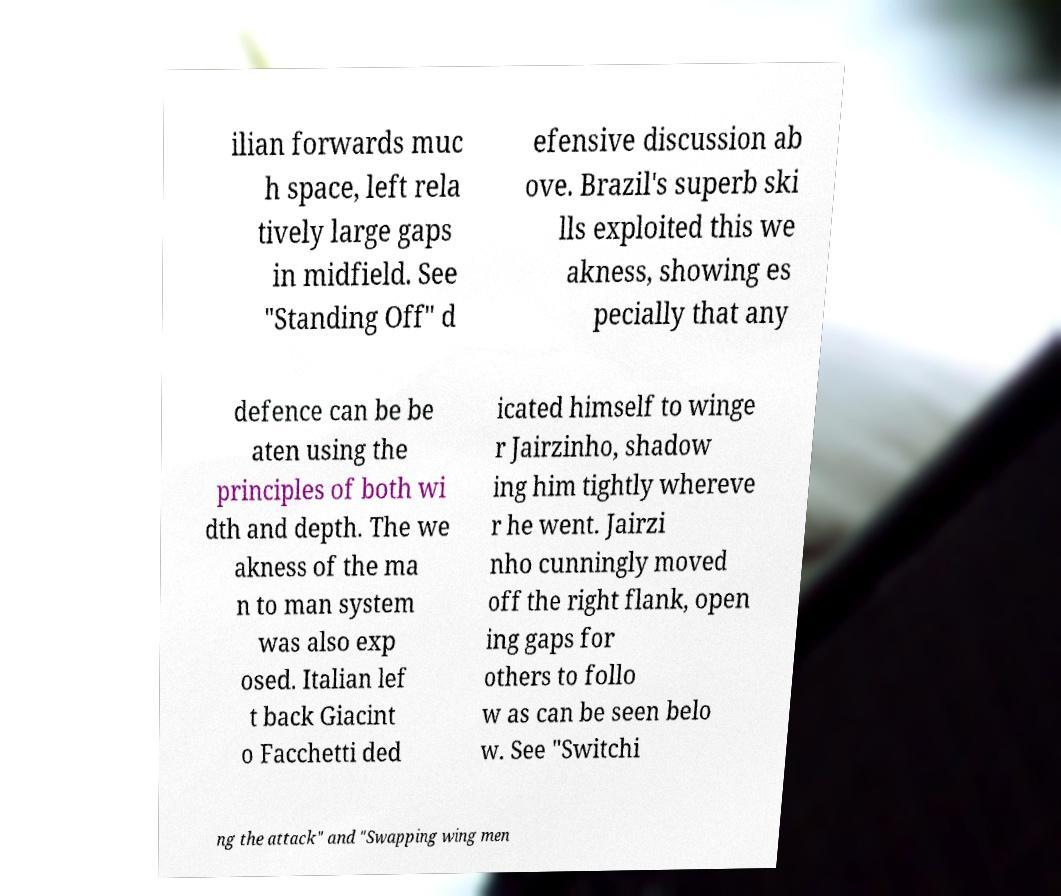Could you extract and type out the text from this image? ilian forwards muc h space, left rela tively large gaps in midfield. See "Standing Off" d efensive discussion ab ove. Brazil's superb ski lls exploited this we akness, showing es pecially that any defence can be be aten using the principles of both wi dth and depth. The we akness of the ma n to man system was also exp osed. Italian lef t back Giacint o Facchetti ded icated himself to winge r Jairzinho, shadow ing him tightly whereve r he went. Jairzi nho cunningly moved off the right flank, open ing gaps for others to follo w as can be seen belo w. See "Switchi ng the attack" and "Swapping wing men 